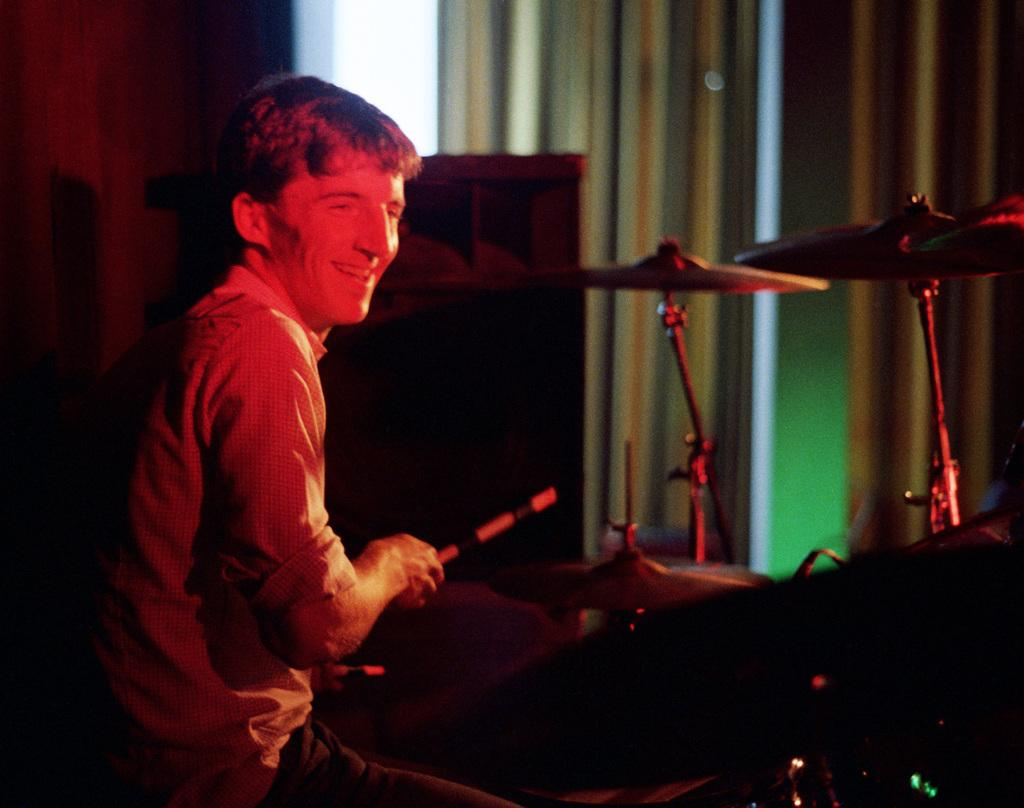What is the man in the image doing? The man is playing a musical instrument in the image. What is the man wearing while playing the instrument? The man is wearing a shirt in the image. How does the man appear while playing the instrument? The man is smiling in the image. What type of silver glue is the man using to play the musical instrument in the image? There is no silver glue present in the image, and the man is not using any glue to play the musical instrument. 